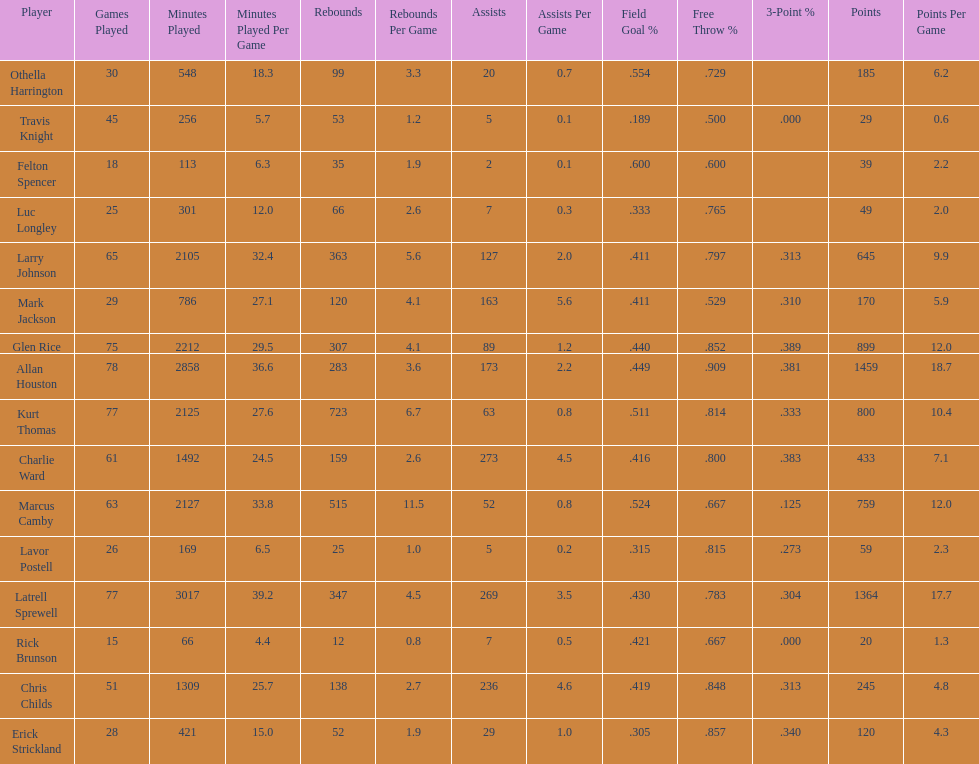How many total points were scored by players averaging over 4 assists per game> 848. 